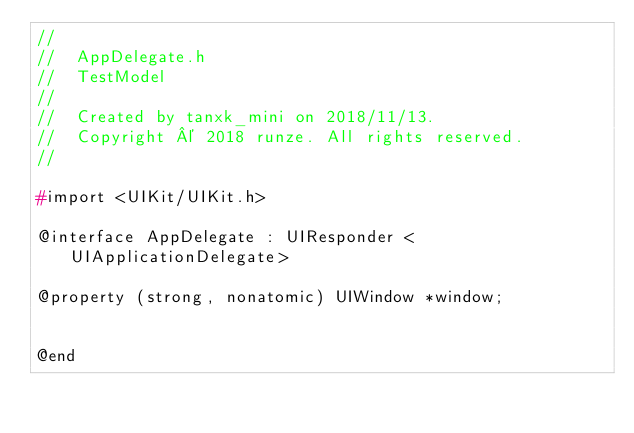Convert code to text. <code><loc_0><loc_0><loc_500><loc_500><_C_>//
//  AppDelegate.h
//  TestModel
//
//  Created by tanxk_mini on 2018/11/13.
//  Copyright © 2018 runze. All rights reserved.
//

#import <UIKit/UIKit.h>

@interface AppDelegate : UIResponder <UIApplicationDelegate>

@property (strong, nonatomic) UIWindow *window;


@end

</code> 